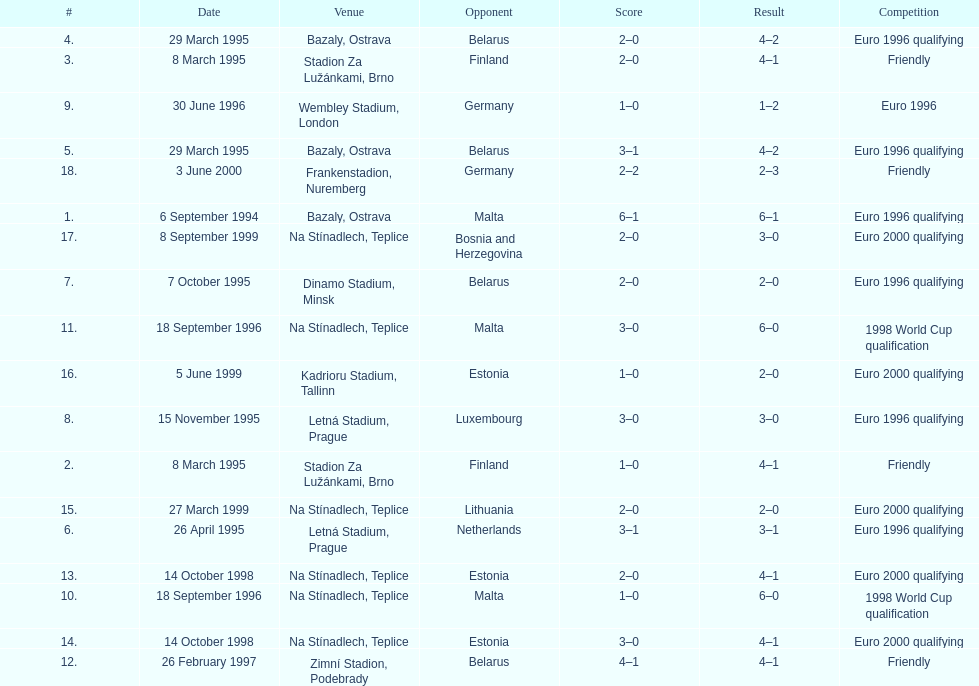What opponent is listed last on the table? Germany. 